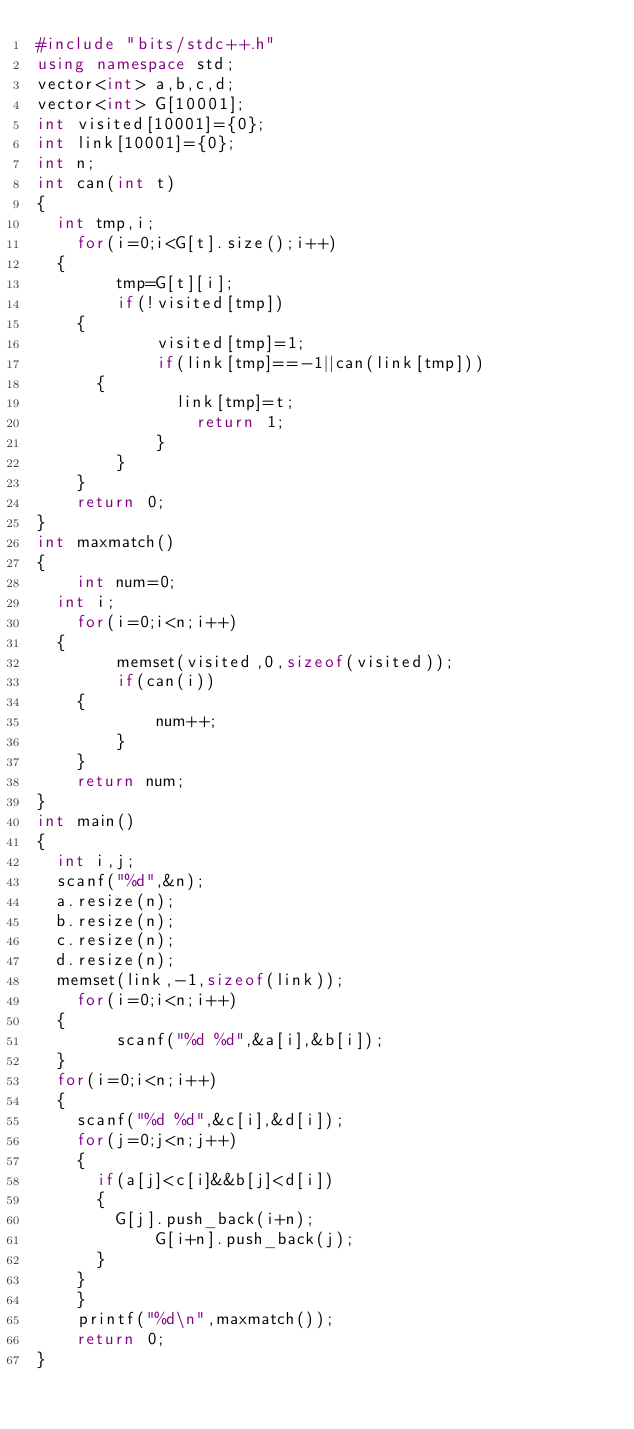<code> <loc_0><loc_0><loc_500><loc_500><_C++_>#include "bits/stdc++.h"
using namespace std;
vector<int> a,b,c,d;
vector<int> G[10001];  
int visited[10001]={0};  
int link[10001]={0};
int n; 
int can(int t)
{  
	int tmp,i;
    for(i=0;i<G[t].size();i++)
	{ 
        tmp=G[t][i];  
        if(!visited[tmp])
		{
            visited[tmp]=1;  
            if(link[tmp]==-1||can(link[tmp]))
			{
            	link[tmp]=t;  
                return 1;  
            }  
        }  
    }  
    return 0;  
}  
int maxmatch()  
{  
    int num=0; 
	int i; 
    for(i=0;i<n;i++)
	{  
        memset(visited,0,sizeof(visited));  
        if(can(i))
		{  
            num++;  
        }  
    }  
    return num;  
}  
int main()  
{  
	int i,j;
	scanf("%d",&n);
	a.resize(n);
	b.resize(n);
	c.resize(n);
	d.resize(n);
	memset(link,-1,sizeof(link));  
    for(i=0;i<n;i++)
	{
        scanf("%d %d",&a[i],&b[i]);    
	}
	for(i=0;i<n;i++)
	{
		scanf("%d %d",&c[i],&d[i]);
		for(j=0;j<n;j++)
		{
			if(a[j]<c[i]&&b[j]<d[i])
			{
				G[j].push_back(i+n);  
        		G[i+n].push_back(j);
			}
		}
    }  
    printf("%d\n",maxmatch());    
    return 0;  
}  </code> 